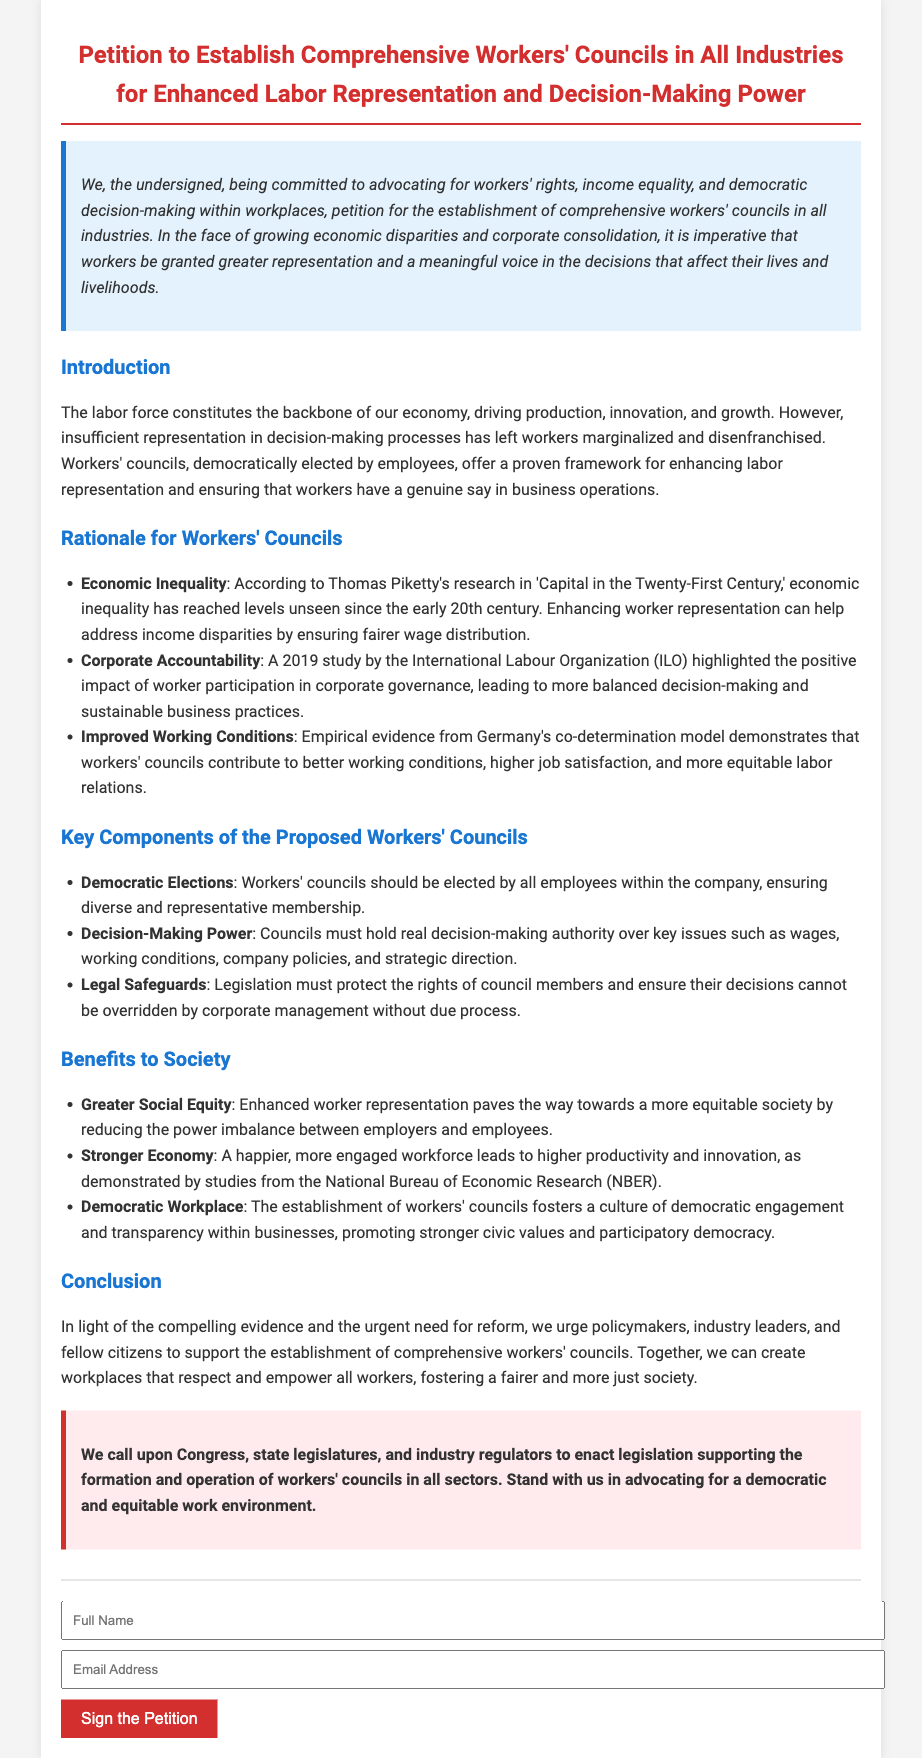What is the title of the petition? The title can be found at the top of the document, which is a clear indication of the petition's purpose.
Answer: Petition to Establish Comprehensive Workers' Councils in All Industries for Enhanced Labor Representation and Decision-Making Power Who is the author of the petition? The petition does not explicitly state an author; instead, it uses "we, the undersigned," implying a collective author.
Answer: Undersigned What is one key component of the proposed workers' councils? This information is detailed in the section outlining the key components of the workers' councils.
Answer: Decision-Making Power Which study discusses the impact of worker participation in corporate governance? This detail is cited in the rationale section of the petition as evidence for the benefits of workers' councils.
Answer: International Labour Organization (ILO) study What economic concept is primarily addressed in the petition? The petition highlights various economic issues, but a key focus is on income inequality.
Answer: Economic Inequality What is a benefit to society mentioned in the document? The benefits section outlines several social advantages due to enhanced worker representation.
Answer: Greater Social Equity What action is being called for in the petition? The conclusion clearly states the desired action from policymakers and others regarding workers' councils.
Answer: Enact legislation supporting the formation and operation of workers' councils How does the petition describe workers' councils? The introduction provides a positive view of workers' councils and their functions.
Answer: Democratically elected by employees 